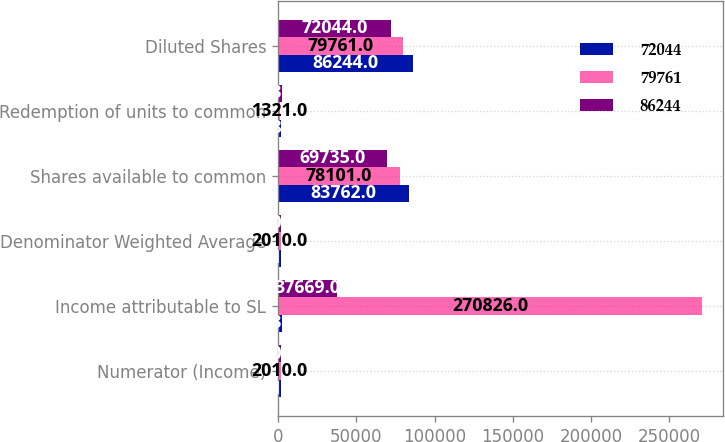Convert chart. <chart><loc_0><loc_0><loc_500><loc_500><stacked_bar_chart><ecel><fcel>Numerator (Income)<fcel>Income attributable to SL<fcel>Denominator Weighted Average<fcel>Shares available to common<fcel>Redemption of units to common<fcel>Diluted Shares<nl><fcel>72044<fcel>2011<fcel>2230<fcel>2011<fcel>83762<fcel>1985<fcel>86244<nl><fcel>79761<fcel>2010<fcel>270826<fcel>2010<fcel>78101<fcel>1321<fcel>79761<nl><fcel>86244<fcel>2009<fcel>37669<fcel>2009<fcel>69735<fcel>2230<fcel>72044<nl></chart> 